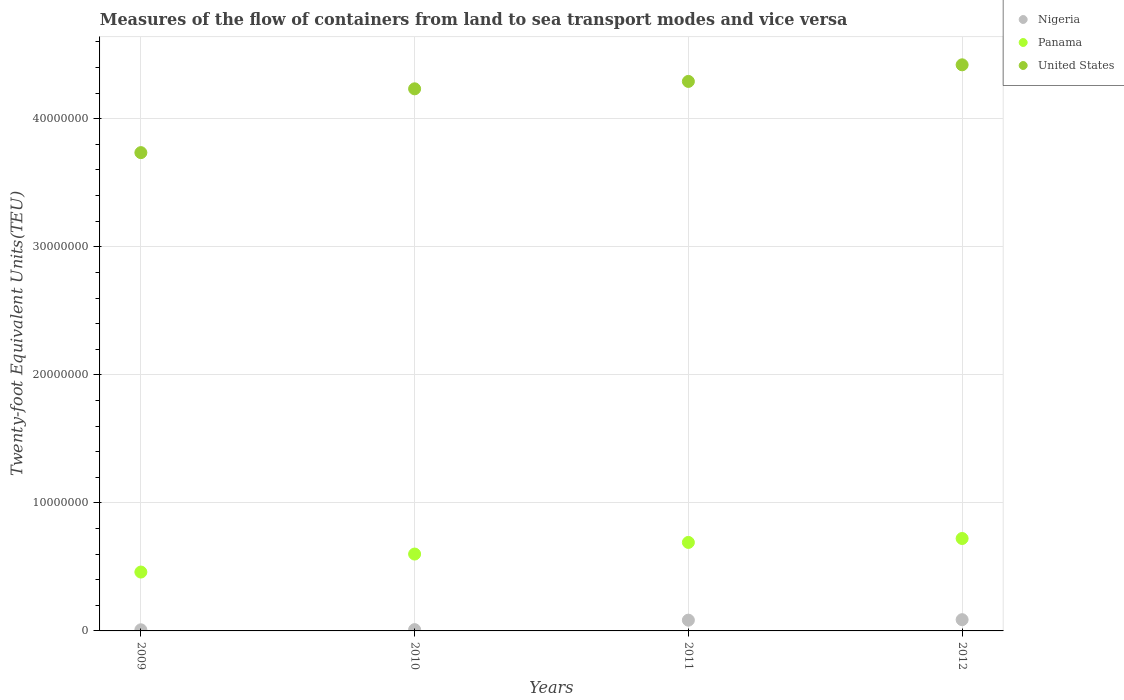How many different coloured dotlines are there?
Your answer should be compact. 3. What is the container port traffic in Panama in 2009?
Provide a succinct answer. 4.60e+06. Across all years, what is the maximum container port traffic in Panama?
Your response must be concise. 7.22e+06. Across all years, what is the minimum container port traffic in Nigeria?
Give a very brief answer. 8.70e+04. In which year was the container port traffic in Nigeria minimum?
Give a very brief answer. 2009. What is the total container port traffic in United States in the graph?
Provide a succinct answer. 1.67e+08. What is the difference between the container port traffic in Nigeria in 2009 and that in 2012?
Provide a succinct answer. -7.91e+05. What is the difference between the container port traffic in Panama in 2012 and the container port traffic in Nigeria in 2009?
Offer a terse response. 7.13e+06. What is the average container port traffic in Nigeria per year?
Your response must be concise. 4.76e+05. In the year 2010, what is the difference between the container port traffic in Panama and container port traffic in United States?
Offer a terse response. -3.63e+07. What is the ratio of the container port traffic in Nigeria in 2009 to that in 2012?
Your response must be concise. 0.1. Is the container port traffic in Nigeria in 2009 less than that in 2012?
Your response must be concise. Yes. What is the difference between the highest and the second highest container port traffic in Panama?
Keep it short and to the point. 3.06e+05. What is the difference between the highest and the lowest container port traffic in United States?
Offer a terse response. 6.86e+06. Is the sum of the container port traffic in United States in 2010 and 2012 greater than the maximum container port traffic in Panama across all years?
Provide a short and direct response. Yes. How many dotlines are there?
Your response must be concise. 3. Does the graph contain any zero values?
Keep it short and to the point. No. How many legend labels are there?
Your response must be concise. 3. How are the legend labels stacked?
Give a very brief answer. Vertical. What is the title of the graph?
Provide a succinct answer. Measures of the flow of containers from land to sea transport modes and vice versa. What is the label or title of the Y-axis?
Your response must be concise. Twenty-foot Equivalent Units(TEU). What is the Twenty-foot Equivalent Units(TEU) of Nigeria in 2009?
Your response must be concise. 8.70e+04. What is the Twenty-foot Equivalent Units(TEU) of Panama in 2009?
Keep it short and to the point. 4.60e+06. What is the Twenty-foot Equivalent Units(TEU) in United States in 2009?
Ensure brevity in your answer.  3.74e+07. What is the Twenty-foot Equivalent Units(TEU) of Nigeria in 2010?
Provide a short and direct response. 1.01e+05. What is the Twenty-foot Equivalent Units(TEU) of Panama in 2010?
Keep it short and to the point. 6.00e+06. What is the Twenty-foot Equivalent Units(TEU) of United States in 2010?
Ensure brevity in your answer.  4.23e+07. What is the Twenty-foot Equivalent Units(TEU) of Nigeria in 2011?
Your answer should be very brief. 8.40e+05. What is the Twenty-foot Equivalent Units(TEU) of Panama in 2011?
Offer a terse response. 6.91e+06. What is the Twenty-foot Equivalent Units(TEU) of United States in 2011?
Your response must be concise. 4.29e+07. What is the Twenty-foot Equivalent Units(TEU) in Nigeria in 2012?
Your answer should be compact. 8.78e+05. What is the Twenty-foot Equivalent Units(TEU) of Panama in 2012?
Your answer should be compact. 7.22e+06. What is the Twenty-foot Equivalent Units(TEU) in United States in 2012?
Offer a very short reply. 4.42e+07. Across all years, what is the maximum Twenty-foot Equivalent Units(TEU) in Nigeria?
Ensure brevity in your answer.  8.78e+05. Across all years, what is the maximum Twenty-foot Equivalent Units(TEU) of Panama?
Provide a short and direct response. 7.22e+06. Across all years, what is the maximum Twenty-foot Equivalent Units(TEU) of United States?
Your response must be concise. 4.42e+07. Across all years, what is the minimum Twenty-foot Equivalent Units(TEU) of Nigeria?
Ensure brevity in your answer.  8.70e+04. Across all years, what is the minimum Twenty-foot Equivalent Units(TEU) of Panama?
Offer a terse response. 4.60e+06. Across all years, what is the minimum Twenty-foot Equivalent Units(TEU) in United States?
Make the answer very short. 3.74e+07. What is the total Twenty-foot Equivalent Units(TEU) in Nigeria in the graph?
Offer a terse response. 1.91e+06. What is the total Twenty-foot Equivalent Units(TEU) of Panama in the graph?
Offer a very short reply. 2.47e+07. What is the total Twenty-foot Equivalent Units(TEU) in United States in the graph?
Your answer should be compact. 1.67e+08. What is the difference between the Twenty-foot Equivalent Units(TEU) in Nigeria in 2009 and that in 2010?
Give a very brief answer. -1.40e+04. What is the difference between the Twenty-foot Equivalent Units(TEU) in Panama in 2009 and that in 2010?
Make the answer very short. -1.41e+06. What is the difference between the Twenty-foot Equivalent Units(TEU) of United States in 2009 and that in 2010?
Your response must be concise. -4.98e+06. What is the difference between the Twenty-foot Equivalent Units(TEU) of Nigeria in 2009 and that in 2011?
Give a very brief answer. -7.53e+05. What is the difference between the Twenty-foot Equivalent Units(TEU) in Panama in 2009 and that in 2011?
Provide a succinct answer. -2.31e+06. What is the difference between the Twenty-foot Equivalent Units(TEU) in United States in 2009 and that in 2011?
Offer a very short reply. -5.56e+06. What is the difference between the Twenty-foot Equivalent Units(TEU) in Nigeria in 2009 and that in 2012?
Keep it short and to the point. -7.91e+05. What is the difference between the Twenty-foot Equivalent Units(TEU) of Panama in 2009 and that in 2012?
Ensure brevity in your answer.  -2.62e+06. What is the difference between the Twenty-foot Equivalent Units(TEU) in United States in 2009 and that in 2012?
Your answer should be very brief. -6.86e+06. What is the difference between the Twenty-foot Equivalent Units(TEU) of Nigeria in 2010 and that in 2011?
Offer a very short reply. -7.39e+05. What is the difference between the Twenty-foot Equivalent Units(TEU) in Panama in 2010 and that in 2011?
Provide a short and direct response. -9.08e+05. What is the difference between the Twenty-foot Equivalent Units(TEU) in United States in 2010 and that in 2011?
Your answer should be compact. -5.78e+05. What is the difference between the Twenty-foot Equivalent Units(TEU) in Nigeria in 2010 and that in 2012?
Your answer should be compact. -7.77e+05. What is the difference between the Twenty-foot Equivalent Units(TEU) of Panama in 2010 and that in 2012?
Ensure brevity in your answer.  -1.21e+06. What is the difference between the Twenty-foot Equivalent Units(TEU) of United States in 2010 and that in 2012?
Your answer should be compact. -1.87e+06. What is the difference between the Twenty-foot Equivalent Units(TEU) in Nigeria in 2011 and that in 2012?
Provide a short and direct response. -3.78e+04. What is the difference between the Twenty-foot Equivalent Units(TEU) in Panama in 2011 and that in 2012?
Offer a terse response. -3.06e+05. What is the difference between the Twenty-foot Equivalent Units(TEU) of United States in 2011 and that in 2012?
Give a very brief answer. -1.30e+06. What is the difference between the Twenty-foot Equivalent Units(TEU) in Nigeria in 2009 and the Twenty-foot Equivalent Units(TEU) in Panama in 2010?
Give a very brief answer. -5.92e+06. What is the difference between the Twenty-foot Equivalent Units(TEU) of Nigeria in 2009 and the Twenty-foot Equivalent Units(TEU) of United States in 2010?
Make the answer very short. -4.23e+07. What is the difference between the Twenty-foot Equivalent Units(TEU) in Panama in 2009 and the Twenty-foot Equivalent Units(TEU) in United States in 2010?
Offer a terse response. -3.77e+07. What is the difference between the Twenty-foot Equivalent Units(TEU) in Nigeria in 2009 and the Twenty-foot Equivalent Units(TEU) in Panama in 2011?
Your answer should be very brief. -6.82e+06. What is the difference between the Twenty-foot Equivalent Units(TEU) in Nigeria in 2009 and the Twenty-foot Equivalent Units(TEU) in United States in 2011?
Give a very brief answer. -4.28e+07. What is the difference between the Twenty-foot Equivalent Units(TEU) in Panama in 2009 and the Twenty-foot Equivalent Units(TEU) in United States in 2011?
Offer a very short reply. -3.83e+07. What is the difference between the Twenty-foot Equivalent Units(TEU) in Nigeria in 2009 and the Twenty-foot Equivalent Units(TEU) in Panama in 2012?
Give a very brief answer. -7.13e+06. What is the difference between the Twenty-foot Equivalent Units(TEU) of Nigeria in 2009 and the Twenty-foot Equivalent Units(TEU) of United States in 2012?
Ensure brevity in your answer.  -4.41e+07. What is the difference between the Twenty-foot Equivalent Units(TEU) of Panama in 2009 and the Twenty-foot Equivalent Units(TEU) of United States in 2012?
Provide a succinct answer. -3.96e+07. What is the difference between the Twenty-foot Equivalent Units(TEU) in Nigeria in 2010 and the Twenty-foot Equivalent Units(TEU) in Panama in 2011?
Provide a succinct answer. -6.81e+06. What is the difference between the Twenty-foot Equivalent Units(TEU) of Nigeria in 2010 and the Twenty-foot Equivalent Units(TEU) of United States in 2011?
Your response must be concise. -4.28e+07. What is the difference between the Twenty-foot Equivalent Units(TEU) of Panama in 2010 and the Twenty-foot Equivalent Units(TEU) of United States in 2011?
Provide a short and direct response. -3.69e+07. What is the difference between the Twenty-foot Equivalent Units(TEU) in Nigeria in 2010 and the Twenty-foot Equivalent Units(TEU) in Panama in 2012?
Make the answer very short. -7.12e+06. What is the difference between the Twenty-foot Equivalent Units(TEU) of Nigeria in 2010 and the Twenty-foot Equivalent Units(TEU) of United States in 2012?
Provide a succinct answer. -4.41e+07. What is the difference between the Twenty-foot Equivalent Units(TEU) in Panama in 2010 and the Twenty-foot Equivalent Units(TEU) in United States in 2012?
Provide a short and direct response. -3.82e+07. What is the difference between the Twenty-foot Equivalent Units(TEU) in Nigeria in 2011 and the Twenty-foot Equivalent Units(TEU) in Panama in 2012?
Offer a terse response. -6.38e+06. What is the difference between the Twenty-foot Equivalent Units(TEU) in Nigeria in 2011 and the Twenty-foot Equivalent Units(TEU) in United States in 2012?
Offer a terse response. -4.34e+07. What is the difference between the Twenty-foot Equivalent Units(TEU) of Panama in 2011 and the Twenty-foot Equivalent Units(TEU) of United States in 2012?
Offer a very short reply. -3.73e+07. What is the average Twenty-foot Equivalent Units(TEU) in Nigeria per year?
Keep it short and to the point. 4.76e+05. What is the average Twenty-foot Equivalent Units(TEU) of Panama per year?
Ensure brevity in your answer.  6.18e+06. What is the average Twenty-foot Equivalent Units(TEU) of United States per year?
Offer a terse response. 4.17e+07. In the year 2009, what is the difference between the Twenty-foot Equivalent Units(TEU) of Nigeria and Twenty-foot Equivalent Units(TEU) of Panama?
Your answer should be very brief. -4.51e+06. In the year 2009, what is the difference between the Twenty-foot Equivalent Units(TEU) of Nigeria and Twenty-foot Equivalent Units(TEU) of United States?
Give a very brief answer. -3.73e+07. In the year 2009, what is the difference between the Twenty-foot Equivalent Units(TEU) in Panama and Twenty-foot Equivalent Units(TEU) in United States?
Offer a terse response. -3.28e+07. In the year 2010, what is the difference between the Twenty-foot Equivalent Units(TEU) of Nigeria and Twenty-foot Equivalent Units(TEU) of Panama?
Your answer should be compact. -5.90e+06. In the year 2010, what is the difference between the Twenty-foot Equivalent Units(TEU) in Nigeria and Twenty-foot Equivalent Units(TEU) in United States?
Offer a terse response. -4.22e+07. In the year 2010, what is the difference between the Twenty-foot Equivalent Units(TEU) of Panama and Twenty-foot Equivalent Units(TEU) of United States?
Keep it short and to the point. -3.63e+07. In the year 2011, what is the difference between the Twenty-foot Equivalent Units(TEU) of Nigeria and Twenty-foot Equivalent Units(TEU) of Panama?
Offer a terse response. -6.07e+06. In the year 2011, what is the difference between the Twenty-foot Equivalent Units(TEU) in Nigeria and Twenty-foot Equivalent Units(TEU) in United States?
Offer a terse response. -4.21e+07. In the year 2011, what is the difference between the Twenty-foot Equivalent Units(TEU) of Panama and Twenty-foot Equivalent Units(TEU) of United States?
Offer a very short reply. -3.60e+07. In the year 2012, what is the difference between the Twenty-foot Equivalent Units(TEU) of Nigeria and Twenty-foot Equivalent Units(TEU) of Panama?
Your answer should be compact. -6.34e+06. In the year 2012, what is the difference between the Twenty-foot Equivalent Units(TEU) of Nigeria and Twenty-foot Equivalent Units(TEU) of United States?
Make the answer very short. -4.33e+07. In the year 2012, what is the difference between the Twenty-foot Equivalent Units(TEU) of Panama and Twenty-foot Equivalent Units(TEU) of United States?
Offer a terse response. -3.70e+07. What is the ratio of the Twenty-foot Equivalent Units(TEU) in Nigeria in 2009 to that in 2010?
Provide a succinct answer. 0.86. What is the ratio of the Twenty-foot Equivalent Units(TEU) in Panama in 2009 to that in 2010?
Your answer should be compact. 0.77. What is the ratio of the Twenty-foot Equivalent Units(TEU) in United States in 2009 to that in 2010?
Offer a terse response. 0.88. What is the ratio of the Twenty-foot Equivalent Units(TEU) in Nigeria in 2009 to that in 2011?
Ensure brevity in your answer.  0.1. What is the ratio of the Twenty-foot Equivalent Units(TEU) in Panama in 2009 to that in 2011?
Provide a succinct answer. 0.67. What is the ratio of the Twenty-foot Equivalent Units(TEU) of United States in 2009 to that in 2011?
Provide a short and direct response. 0.87. What is the ratio of the Twenty-foot Equivalent Units(TEU) in Nigeria in 2009 to that in 2012?
Provide a short and direct response. 0.1. What is the ratio of the Twenty-foot Equivalent Units(TEU) of Panama in 2009 to that in 2012?
Offer a very short reply. 0.64. What is the ratio of the Twenty-foot Equivalent Units(TEU) in United States in 2009 to that in 2012?
Make the answer very short. 0.84. What is the ratio of the Twenty-foot Equivalent Units(TEU) of Nigeria in 2010 to that in 2011?
Provide a short and direct response. 0.12. What is the ratio of the Twenty-foot Equivalent Units(TEU) in Panama in 2010 to that in 2011?
Your answer should be compact. 0.87. What is the ratio of the Twenty-foot Equivalent Units(TEU) of United States in 2010 to that in 2011?
Keep it short and to the point. 0.99. What is the ratio of the Twenty-foot Equivalent Units(TEU) in Nigeria in 2010 to that in 2012?
Your answer should be compact. 0.12. What is the ratio of the Twenty-foot Equivalent Units(TEU) in Panama in 2010 to that in 2012?
Make the answer very short. 0.83. What is the ratio of the Twenty-foot Equivalent Units(TEU) in United States in 2010 to that in 2012?
Provide a short and direct response. 0.96. What is the ratio of the Twenty-foot Equivalent Units(TEU) in Nigeria in 2011 to that in 2012?
Give a very brief answer. 0.96. What is the ratio of the Twenty-foot Equivalent Units(TEU) in Panama in 2011 to that in 2012?
Provide a short and direct response. 0.96. What is the ratio of the Twenty-foot Equivalent Units(TEU) of United States in 2011 to that in 2012?
Make the answer very short. 0.97. What is the difference between the highest and the second highest Twenty-foot Equivalent Units(TEU) in Nigeria?
Your answer should be very brief. 3.78e+04. What is the difference between the highest and the second highest Twenty-foot Equivalent Units(TEU) in Panama?
Offer a very short reply. 3.06e+05. What is the difference between the highest and the second highest Twenty-foot Equivalent Units(TEU) in United States?
Your answer should be very brief. 1.30e+06. What is the difference between the highest and the lowest Twenty-foot Equivalent Units(TEU) of Nigeria?
Give a very brief answer. 7.91e+05. What is the difference between the highest and the lowest Twenty-foot Equivalent Units(TEU) of Panama?
Your answer should be very brief. 2.62e+06. What is the difference between the highest and the lowest Twenty-foot Equivalent Units(TEU) in United States?
Keep it short and to the point. 6.86e+06. 